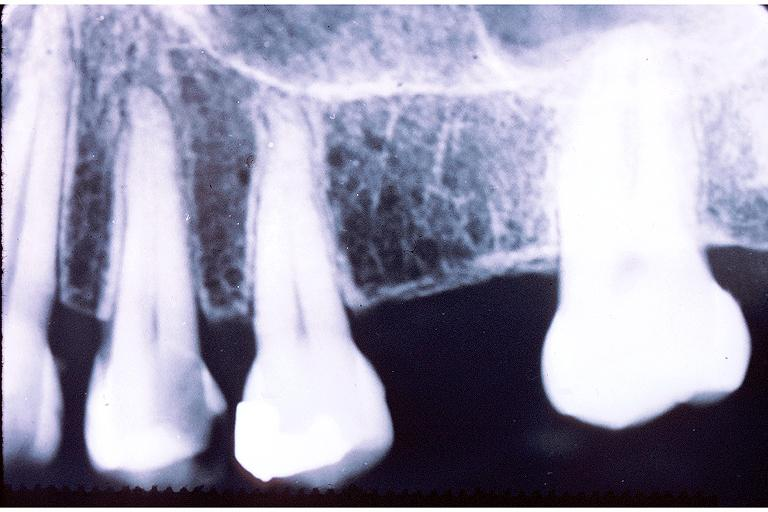what does this image show?
Answer the question using a single word or phrase. Caries 